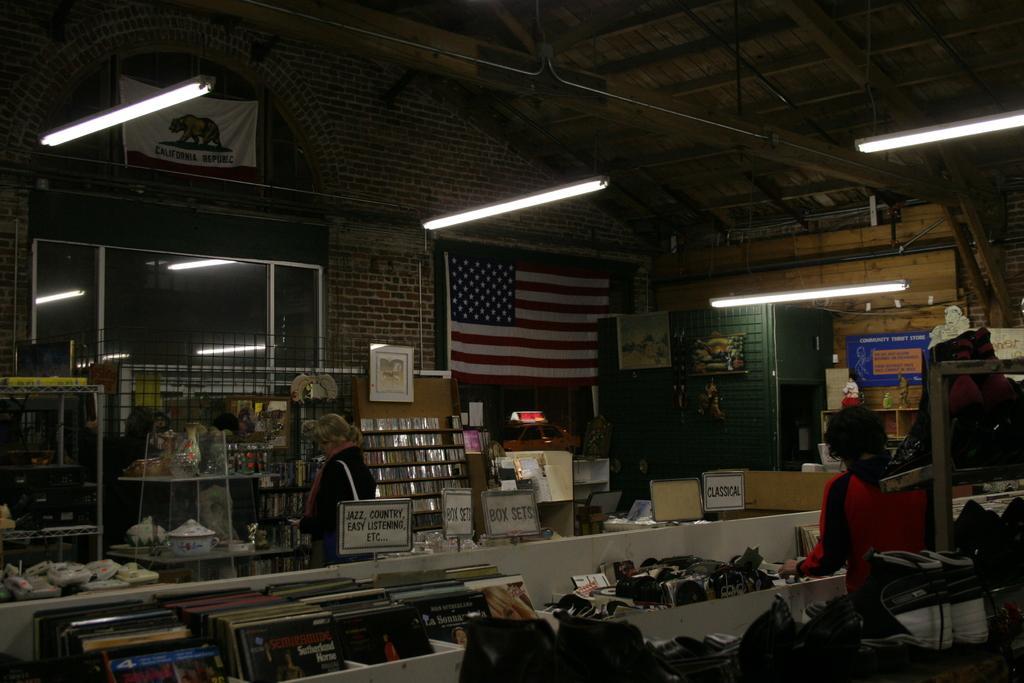Could you give a brief overview of what you see in this image? The image is taken in a room. At the top there are lights. In the center of the picture there are flowers, name boards, flag, flower vase, posters, shelves, cards, window and many other objects. In the foreground there are covers, cds, shoes and other objects. 